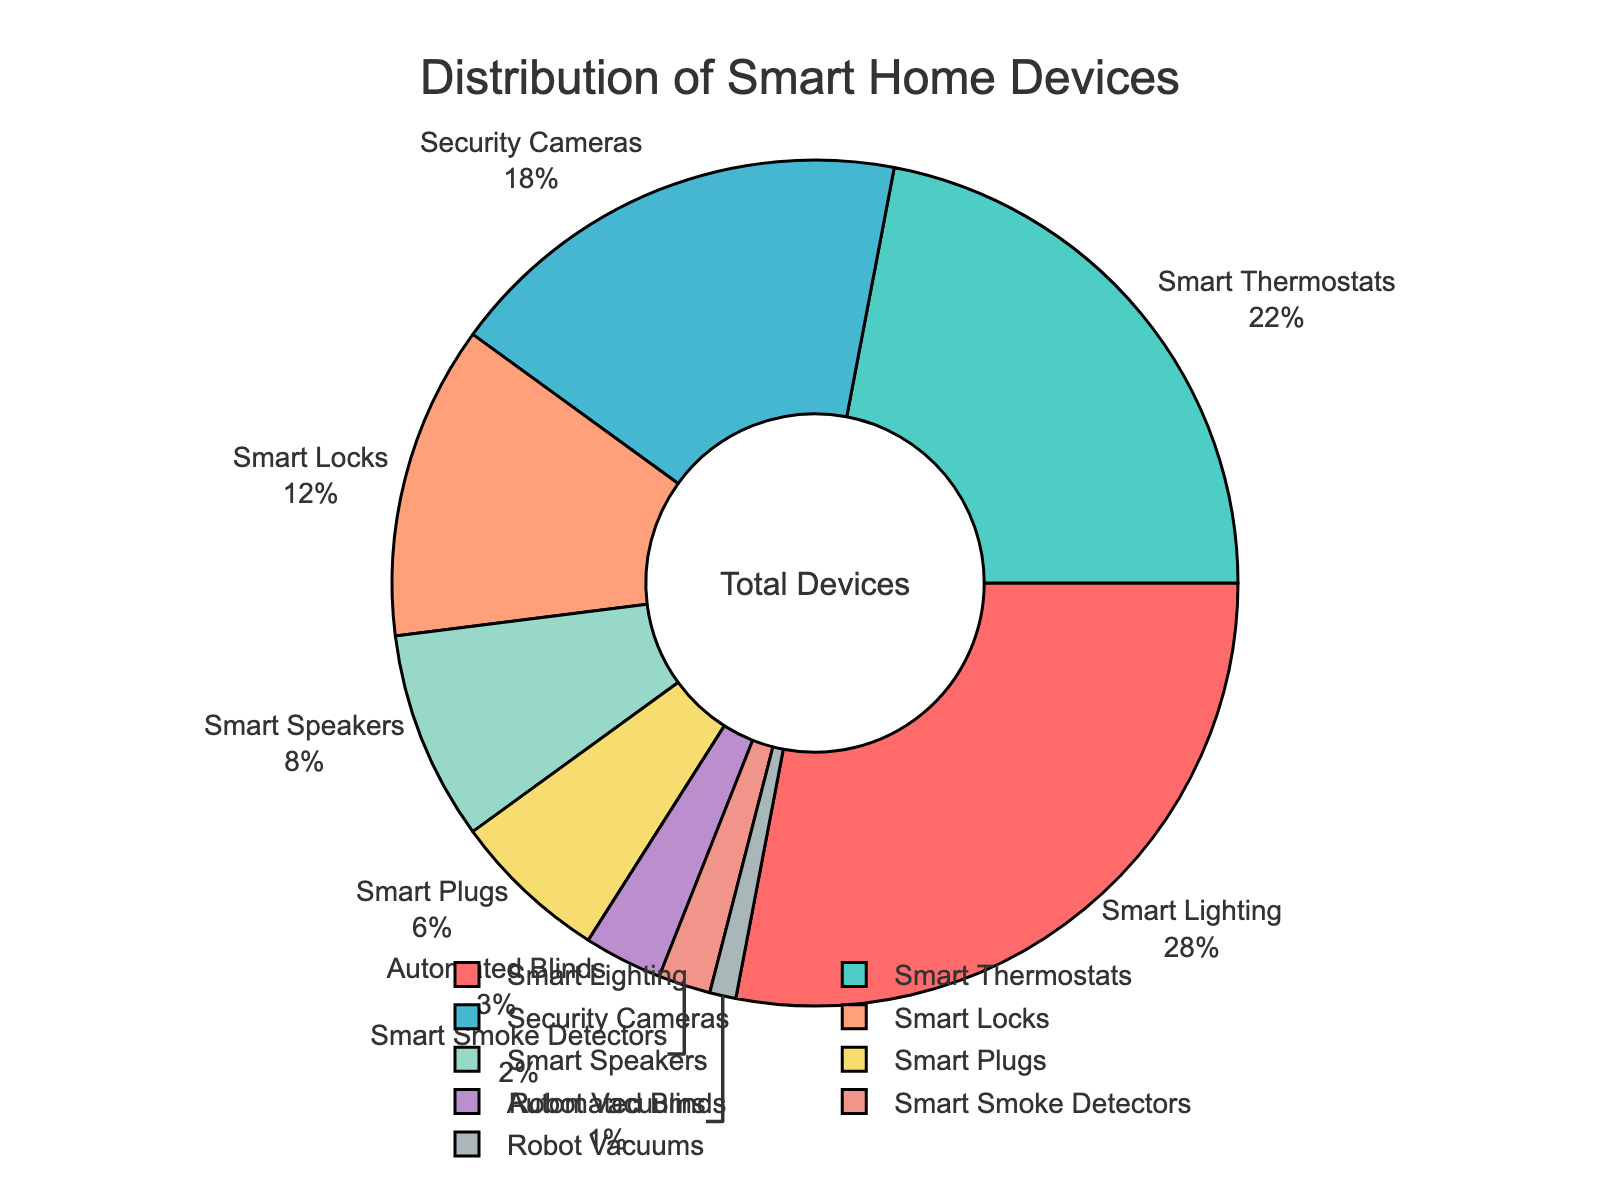What category represents the largest portion of the pie chart? The largest slice of the pie chart corresponds to the "Smart Lighting" category. You can determine this by observing the slice with the largest area.
Answer: Smart Lighting What is the combined percentage of Smart Thermostats and Security Cameras? To find the combined percentage, add the percentage values for Smart Thermostats and Security Cameras: 22% + 18% = 40%.
Answer: 40% How much more prevalent are Smart Lighting devices compared to Smart Speakers? To determine the difference, subtract the percentage of Smart Speakers from the percentage of Smart Lighting: 28% - 8% = 20%.
Answer: 20% Which category has the smallest percentage in the chart? The smallest slice in the pie chart represents "Robot Vacuums" with a percentage of 1%.
Answer: Robot Vacuums What percentage of the devices are used for security purposes? The categories related to security are Security Cameras and Smart Locks. Adding their percentages gives: 18% + 12% = 30%.
Answer: 30% Which category has a higher percentage: Smart Plugs or Automated Blinds? By comparing the two slices in the pie chart, Smart Plugs have a higher percentage (6%) than Automated Blinds (3%).
Answer: Smart Plugs How many categories have a percentage greater than 15%? The categories with percentages greater than 15% are Smart Lighting, Smart Thermostats, and Security Cameras. Counting these gives a total of 3 categories.
Answer: 3 Are Smart Locks more or less prevalent than Smart Speakers? Comparing the sizes of the slices for these categories, Smart Locks (12%) are more prevalent than Smart Speakers (8%).
Answer: More What is the total percentage for categories below 5%? The categories below 5% are Automated Blinds, Smart Smoke Detectors, and Robot Vacuums. Adding their percentages gives: 3% + 2% + 1% = 6%.
Answer: 6% If you combine the percentages of Smart Plugs and Automated Blinds, does this combined percentage exceed that of Smart Thermostats? Adding the percentages of Smart Plugs and Automated Blinds gives 6% + 3% = 9%. This combined percentage is less than the 22% for Smart Thermostats.
Answer: No 